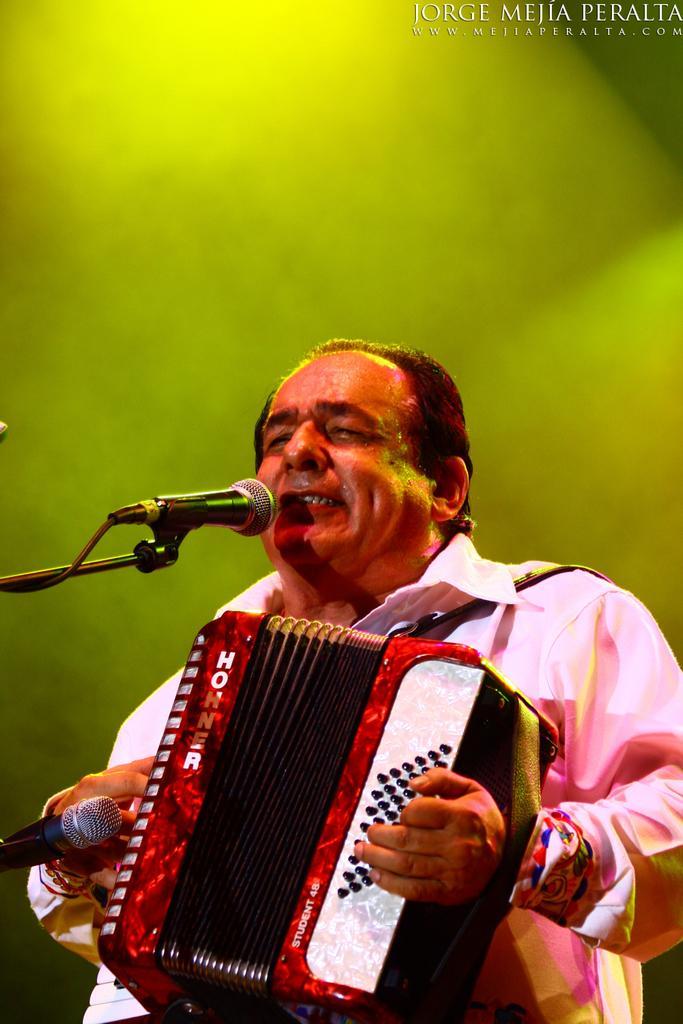Can you describe this image briefly? In this image we can see a man holding the musical instrument and standing in front of the mics. The background is in green color. In the top right corner we can see the text. 